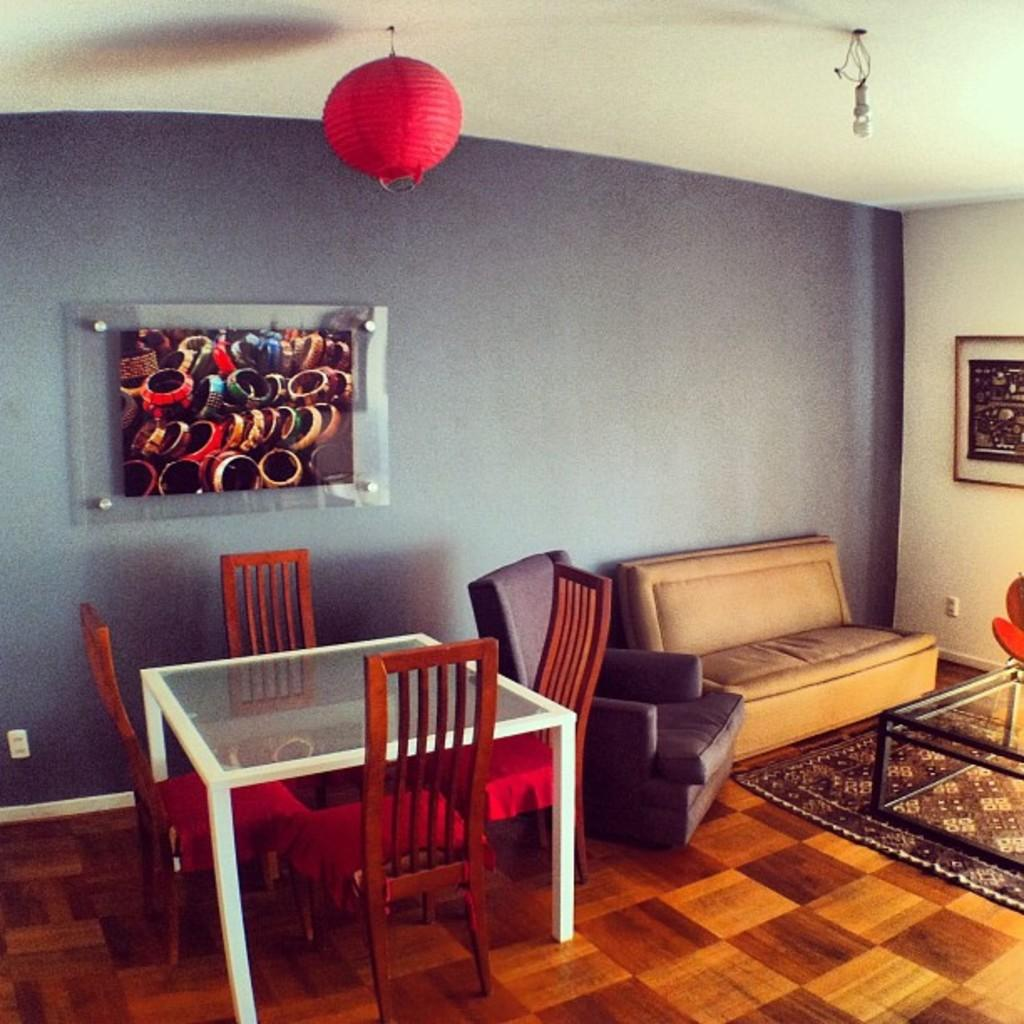What type of space is shown in the image? The image depicts the interior of a room. What furniture is present in the room? There are sofas, a table, and chairs in the room. Are there any decorative elements in the room? Yes, wall paintings are present in the room. Can you hear the sound of thunder in the room? There is no mention of thunder or any sound in the image, so it cannot be heard. 